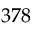Convert formula to latex. <formula><loc_0><loc_0><loc_500><loc_500>3 7 8</formula> 